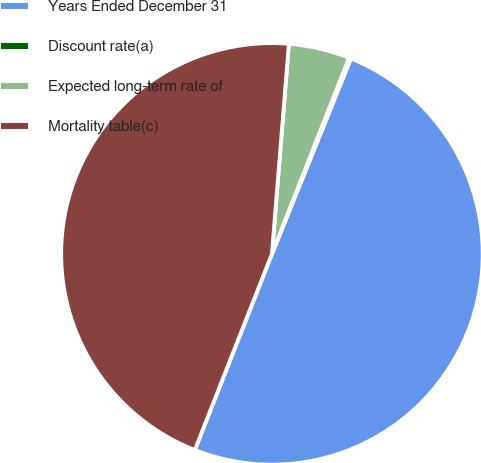Convert chart to OTSL. <chart><loc_0><loc_0><loc_500><loc_500><pie_chart><fcel>Years Ended December 31<fcel>Discount rate(a)<fcel>Expected long-term rate of<fcel>Mortality table(c)<nl><fcel>49.85%<fcel>0.15%<fcel>4.68%<fcel>45.32%<nl></chart> 